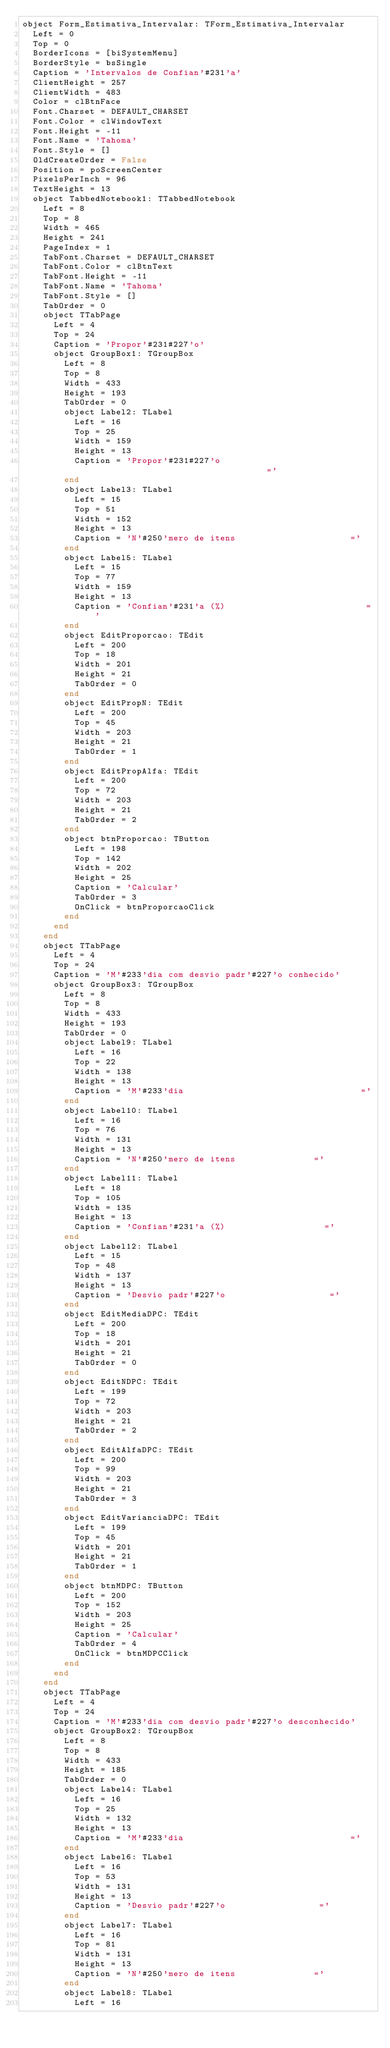<code> <loc_0><loc_0><loc_500><loc_500><_Pascal_>object Form_Estimativa_Intervalar: TForm_Estimativa_Intervalar
  Left = 0
  Top = 0
  BorderIcons = [biSystemMenu]
  BorderStyle = bsSingle
  Caption = 'Intervalos de Confian'#231'a'
  ClientHeight = 257
  ClientWidth = 483
  Color = clBtnFace
  Font.Charset = DEFAULT_CHARSET
  Font.Color = clWindowText
  Font.Height = -11
  Font.Name = 'Tahoma'
  Font.Style = []
  OldCreateOrder = False
  Position = poScreenCenter
  PixelsPerInch = 96
  TextHeight = 13
  object TabbedNotebook1: TTabbedNotebook
    Left = 8
    Top = 8
    Width = 465
    Height = 241
    PageIndex = 1
    TabFont.Charset = DEFAULT_CHARSET
    TabFont.Color = clBtnText
    TabFont.Height = -11
    TabFont.Name = 'Tahoma'
    TabFont.Style = []
    TabOrder = 0
    object TTabPage
      Left = 4
      Top = 24
      Caption = 'Propor'#231#227'o'
      object GroupBox1: TGroupBox
        Left = 8
        Top = 8
        Width = 433
        Height = 193
        TabOrder = 0
        object Label2: TLabel
          Left = 16
          Top = 25
          Width = 159
          Height = 13
          Caption = 'Propor'#231#227'o                                  ='
        end
        object Label3: TLabel
          Left = 15
          Top = 51
          Width = 152
          Height = 13
          Caption = 'N'#250'mero de itens                      ='
        end
        object Label5: TLabel
          Left = 15
          Top = 77
          Width = 159
          Height = 13
          Caption = 'Confian'#231'a (%)                           ='
        end
        object EditProporcao: TEdit
          Left = 200
          Top = 18
          Width = 201
          Height = 21
          TabOrder = 0
        end
        object EditPropN: TEdit
          Left = 200
          Top = 45
          Width = 203
          Height = 21
          TabOrder = 1
        end
        object EditPropAlfa: TEdit
          Left = 200
          Top = 72
          Width = 203
          Height = 21
          TabOrder = 2
        end
        object btnProporcao: TButton
          Left = 198
          Top = 142
          Width = 202
          Height = 25
          Caption = 'Calcular'
          TabOrder = 3
          OnClick = btnProporcaoClick
        end
      end
    end
    object TTabPage
      Left = 4
      Top = 24
      Caption = 'M'#233'dia com desvio padr'#227'o conhecido'
      object GroupBox3: TGroupBox
        Left = 8
        Top = 8
        Width = 433
        Height = 193
        TabOrder = 0
        object Label9: TLabel
          Left = 16
          Top = 22
          Width = 138
          Height = 13
          Caption = 'M'#233'dia                                  ='
        end
        object Label10: TLabel
          Left = 16
          Top = 76
          Width = 131
          Height = 13
          Caption = 'N'#250'mero de itens               ='
        end
        object Label11: TLabel
          Left = 18
          Top = 105
          Width = 135
          Height = 13
          Caption = 'Confian'#231'a (%)                   ='
        end
        object Label12: TLabel
          Left = 15
          Top = 48
          Width = 137
          Height = 13
          Caption = 'Desvio padr'#227'o                    ='
        end
        object EditMediaDPC: TEdit
          Left = 200
          Top = 18
          Width = 201
          Height = 21
          TabOrder = 0
        end
        object EditNDPC: TEdit
          Left = 199
          Top = 72
          Width = 203
          Height = 21
          TabOrder = 2
        end
        object EditAlfaDPC: TEdit
          Left = 200
          Top = 99
          Width = 203
          Height = 21
          TabOrder = 3
        end
        object EditVarianciaDPC: TEdit
          Left = 199
          Top = 45
          Width = 201
          Height = 21
          TabOrder = 1
        end
        object btnMDPC: TButton
          Left = 200
          Top = 152
          Width = 203
          Height = 25
          Caption = 'Calcular'
          TabOrder = 4
          OnClick = btnMDPCClick
        end
      end
    end
    object TTabPage
      Left = 4
      Top = 24
      Caption = 'M'#233'dia com desvio padr'#227'o desconhecido'
      object GroupBox2: TGroupBox
        Left = 8
        Top = 8
        Width = 433
        Height = 185
        TabOrder = 0
        object Label4: TLabel
          Left = 16
          Top = 25
          Width = 132
          Height = 13
          Caption = 'M'#233'dia                                ='
        end
        object Label6: TLabel
          Left = 16
          Top = 53
          Width = 131
          Height = 13
          Caption = 'Desvio padr'#227'o                  ='
        end
        object Label7: TLabel
          Left = 16
          Top = 81
          Width = 131
          Height = 13
          Caption = 'N'#250'mero de itens               ='
        end
        object Label8: TLabel
          Left = 16</code> 